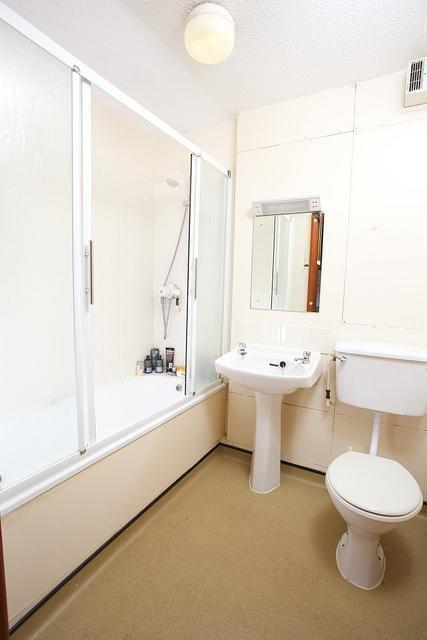How many elephants are in the picture?
Give a very brief answer. 0. 